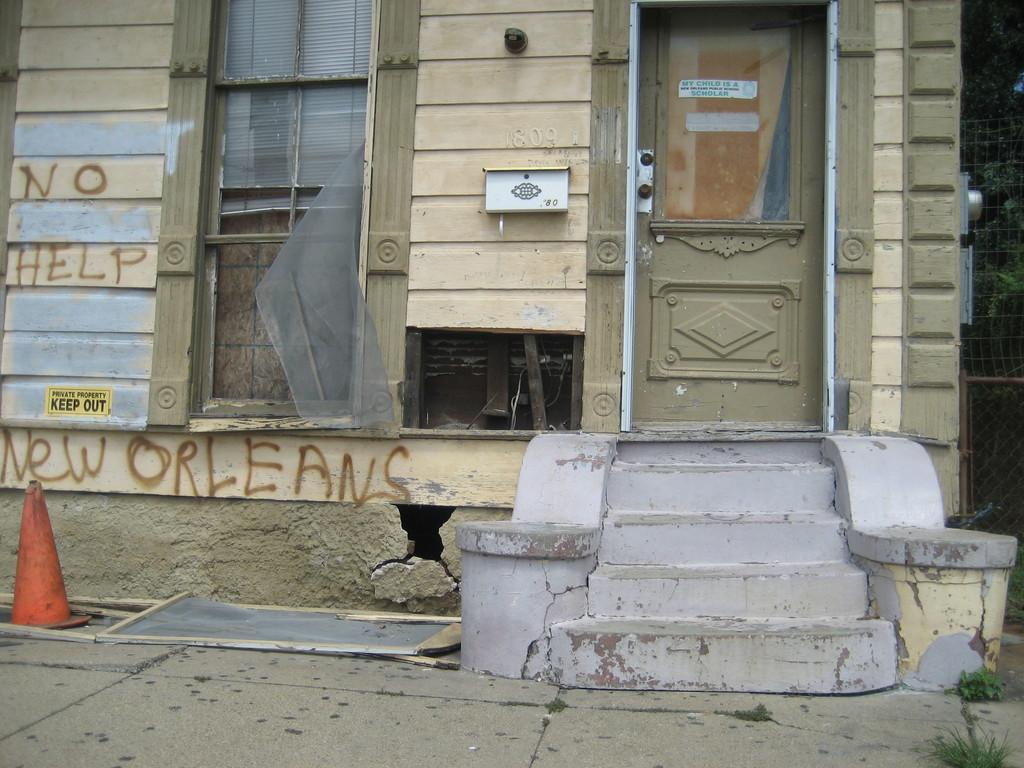Could you give a brief overview of what you see in this image? Here in this picture we can see a front door of a building and we can see steps present in front of the door and on the wall we can see a drop box present and beside that we can see a window present and we can see something written on the walls over there and we can also see a traffic cone on the left side and on the right side we can see plants present over there. 